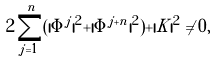<formula> <loc_0><loc_0><loc_500><loc_500>2 \sum _ { j = 1 } ^ { n } ( | \Phi ^ { j } | ^ { 2 } + | \Phi ^ { j + n } | ^ { 2 } ) + | K | ^ { 2 } \neq 0 ,</formula> 